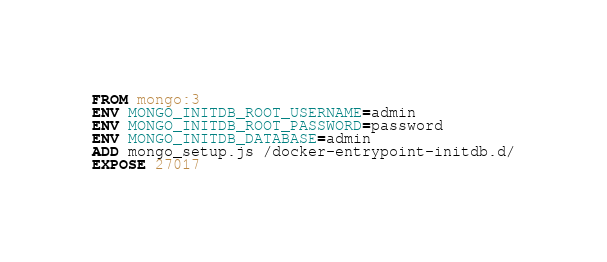<code> <loc_0><loc_0><loc_500><loc_500><_Dockerfile_>FROM mongo:3
ENV MONGO_INITDB_ROOT_USERNAME=admin
ENV MONGO_INITDB_ROOT_PASSWORD=password
ENV MONGO_INITDB_DATABASE=admin
ADD mongo_setup.js /docker-entrypoint-initdb.d/
EXPOSE 27017
</code> 